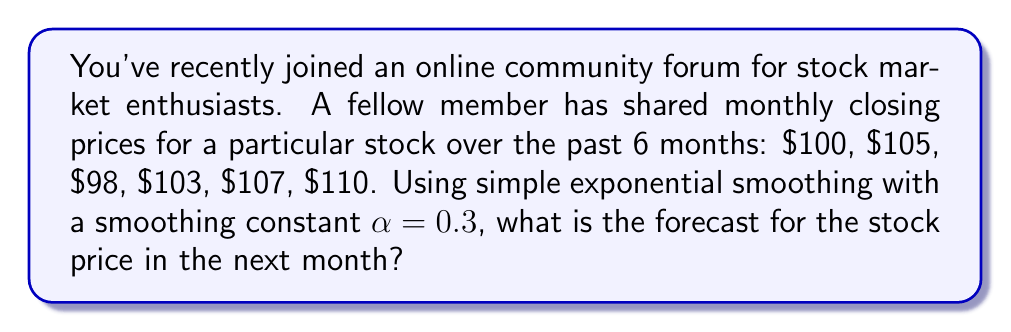Teach me how to tackle this problem. To solve this problem using simple exponential smoothing, we'll follow these steps:

1) The formula for simple exponential smoothing is:

   $$F_{t+1} = \alpha Y_t + (1-\alpha)F_t$$

   Where:
   $F_{t+1}$ is the forecast for the next period
   $\alpha$ is the smoothing constant (0.3 in this case)
   $Y_t$ is the actual value at time t
   $F_t$ is the forecast for the current period

2) We start by setting the initial forecast $F_1$ equal to the first actual value:

   $F_1 = 100$

3) Then we calculate each subsequent forecast:

   $F_2 = 0.3(100) + 0.7(100) = 100$
   $F_3 = 0.3(105) + 0.7(100) = 101.5$
   $F_4 = 0.3(98) + 0.7(101.5) = 100.45$
   $F_5 = 0.3(103) + 0.7(100.45) = 101.215$
   $F_6 = 0.3(107) + 0.7(101.215) = 103.0505$

4) Finally, we calculate the forecast for the 7th month:

   $F_7 = 0.3(110) + 0.7(103.0505) = 105.1354$

Therefore, the forecast for the next month's stock price is approximately $105.14.
Answer: $105.14 